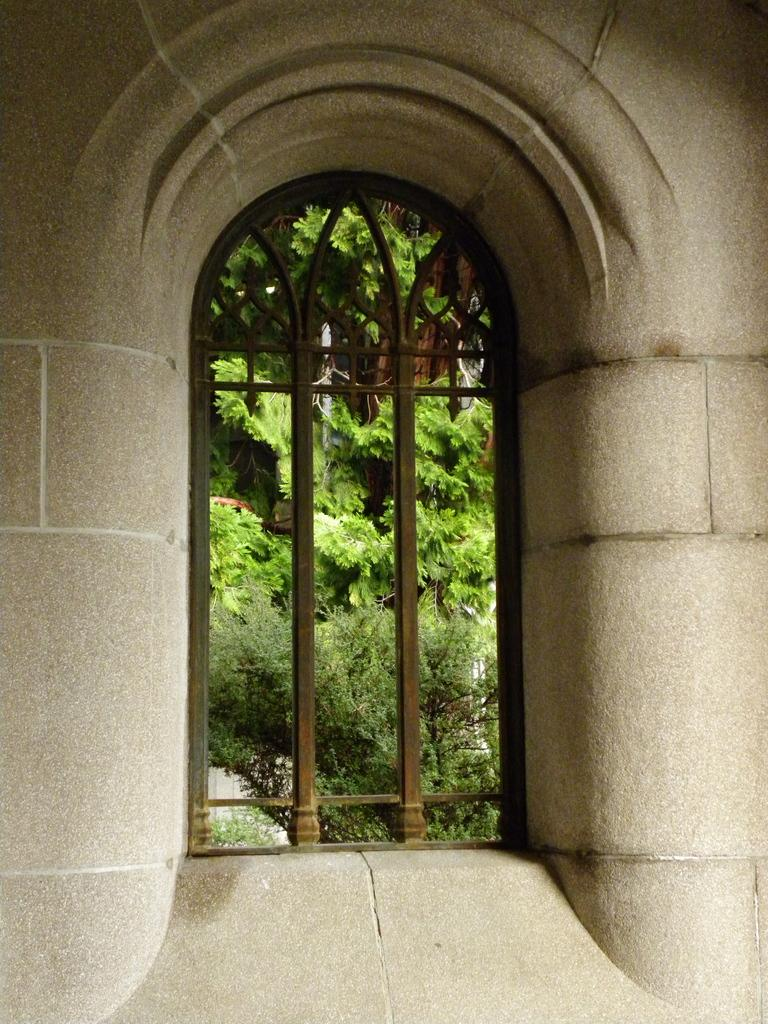What type of structure can be seen in the image? There is a wall in the image. What architectural feature is present in the wall? There is a window in the image. What can be seen through the window in the image? Trees are visible through the window in the image. What type of profit can be seen being made by the trees in the image? There is no indication of profit or any financial activity in the image; it simply features a wall with a window and trees visible through it. What type of knife can be seen being used by the trees in the image? There is no knife or any tool visible in the image; it only shows trees visible through the window. 